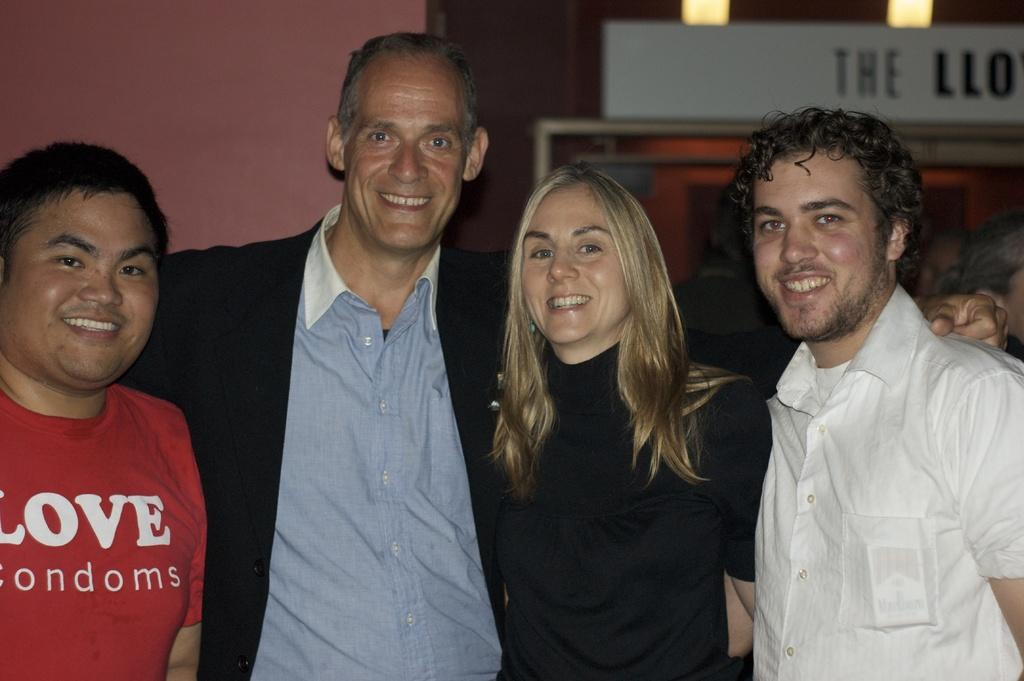How many people are visible in the image? There are four people standing in the image. Are there any other people in the image besides the four standing people? Yes, there are additional people behind the four standing people. What can be seen in the background of the image? There is a wall and a door in the background of the image. What type of liquid is being poured out of the fan in the image? There is no fan or liquid present in the image. 